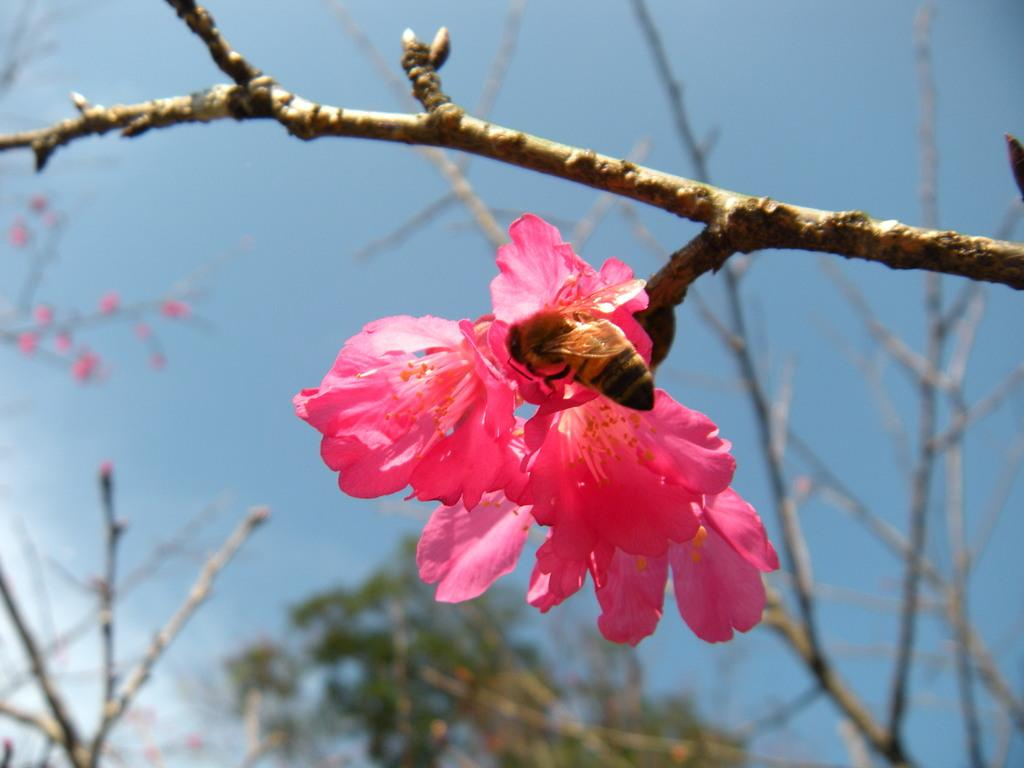What color are the flowers in the image? The flowers in the image are pink. What type of plant do the flowers belong to? The flowers belong to a plant. What insect can be seen on the flowers? There is a honey bee on the flowers. What is the condition of the background in the image? The background of the image is blurred. What type of vegetation is visible in the background of the image? Trees are visible in the background of the image. What color is the sky in the background of the image? The sky is blue in the background of the image. What type of medical treatment is being administered in the image? There is no medical treatment or hospital setting present in the image; it features pink flowers, a honey bee, and a blurred background with trees and a blue sky. 